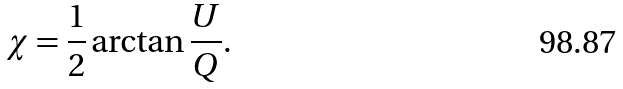<formula> <loc_0><loc_0><loc_500><loc_500>\chi = \frac { 1 } { 2 } \arctan \frac { U } { Q } .</formula> 